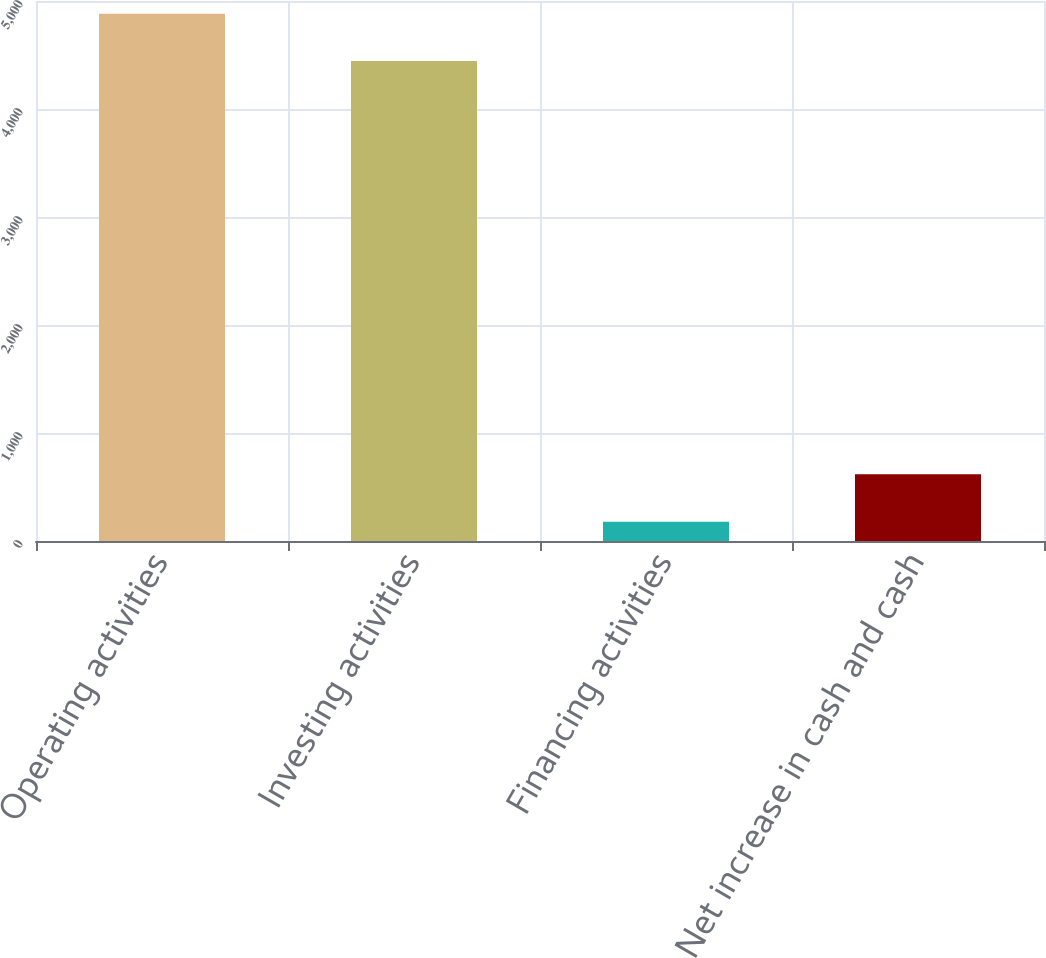Convert chart to OTSL. <chart><loc_0><loc_0><loc_500><loc_500><bar_chart><fcel>Operating activities<fcel>Investing activities<fcel>Financing activities<fcel>Net increase in cash and cash<nl><fcel>4882.9<fcel>4444<fcel>178<fcel>616.9<nl></chart> 